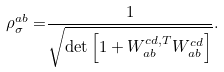Convert formula to latex. <formula><loc_0><loc_0><loc_500><loc_500>\rho _ { \sigma } ^ { a b } = & \frac { 1 } { \sqrt { \det \left [ 1 + W _ { a b } ^ { c d , T } W _ { a b } ^ { c d } \right ] } } .</formula> 